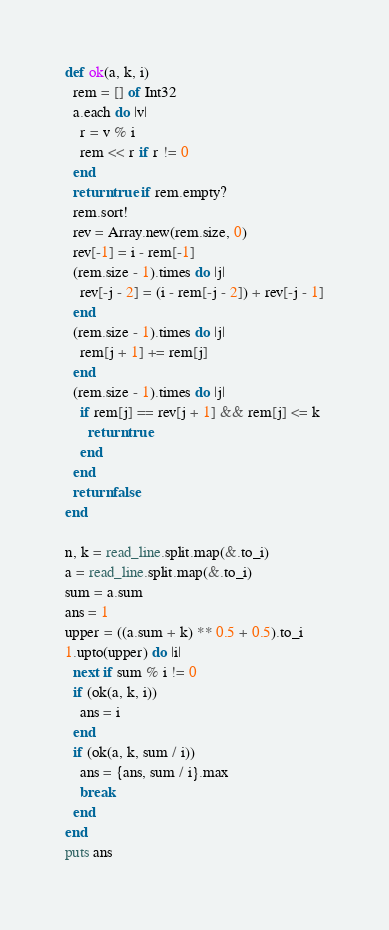Convert code to text. <code><loc_0><loc_0><loc_500><loc_500><_Crystal_>def ok(a, k, i)
  rem = [] of Int32
  a.each do |v|
    r = v % i
    rem << r if r != 0
  end
  return true if rem.empty?
  rem.sort!
  rev = Array.new(rem.size, 0)
  rev[-1] = i - rem[-1]
  (rem.size - 1).times do |j|
    rev[-j - 2] = (i - rem[-j - 2]) + rev[-j - 1]
  end
  (rem.size - 1).times do |j|
    rem[j + 1] += rem[j]
  end
  (rem.size - 1).times do |j|
    if rem[j] == rev[j + 1] && rem[j] <= k
      return true
    end
  end
  return false
end

n, k = read_line.split.map(&.to_i)
a = read_line.split.map(&.to_i)
sum = a.sum
ans = 1
upper = ((a.sum + k) ** 0.5 + 0.5).to_i
1.upto(upper) do |i|
  next if sum % i != 0
  if (ok(a, k, i))
    ans = i
  end
  if (ok(a, k, sum / i))
    ans = {ans, sum / i}.max
    break
  end
end
puts ans
</code> 